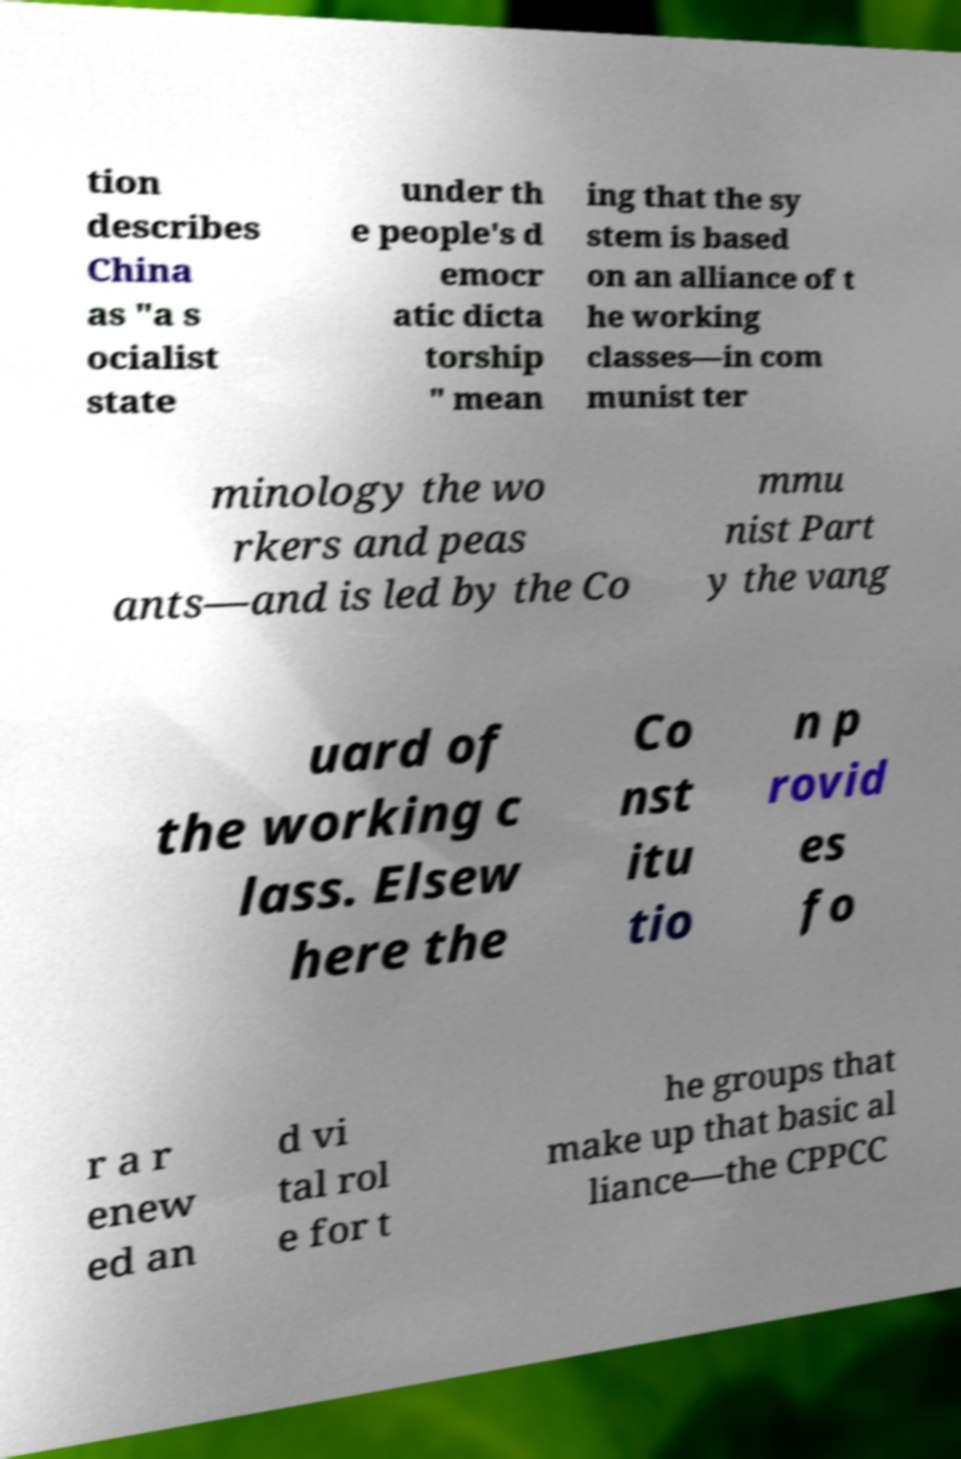Can you read and provide the text displayed in the image?This photo seems to have some interesting text. Can you extract and type it out for me? tion describes China as "a s ocialist state under th e people's d emocr atic dicta torship " mean ing that the sy stem is based on an alliance of t he working classes—in com munist ter minology the wo rkers and peas ants—and is led by the Co mmu nist Part y the vang uard of the working c lass. Elsew here the Co nst itu tio n p rovid es fo r a r enew ed an d vi tal rol e for t he groups that make up that basic al liance—the CPPCC 